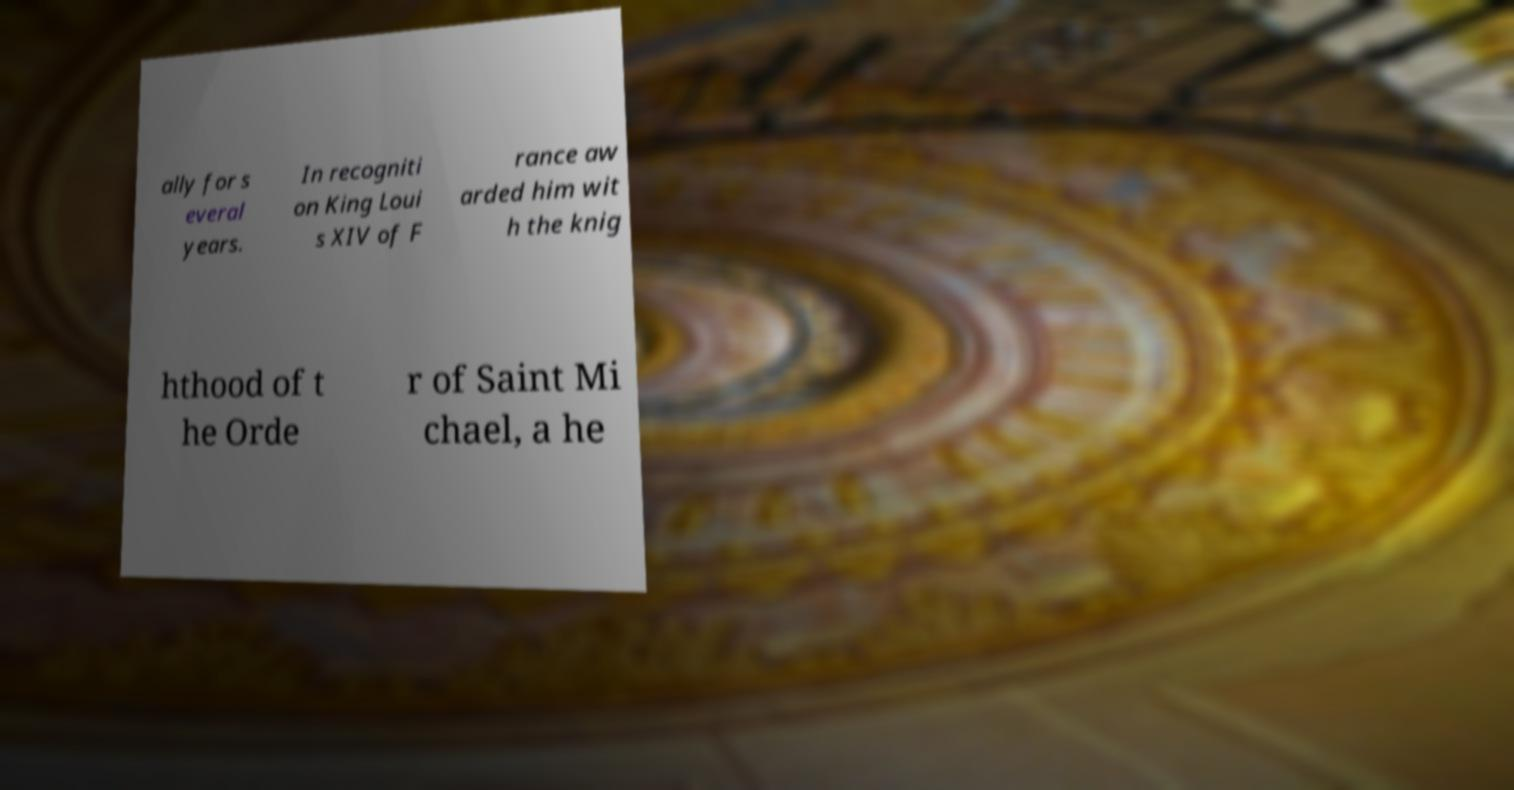Could you assist in decoding the text presented in this image and type it out clearly? ally for s everal years. In recogniti on King Loui s XIV of F rance aw arded him wit h the knig hthood of t he Orde r of Saint Mi chael, a he 